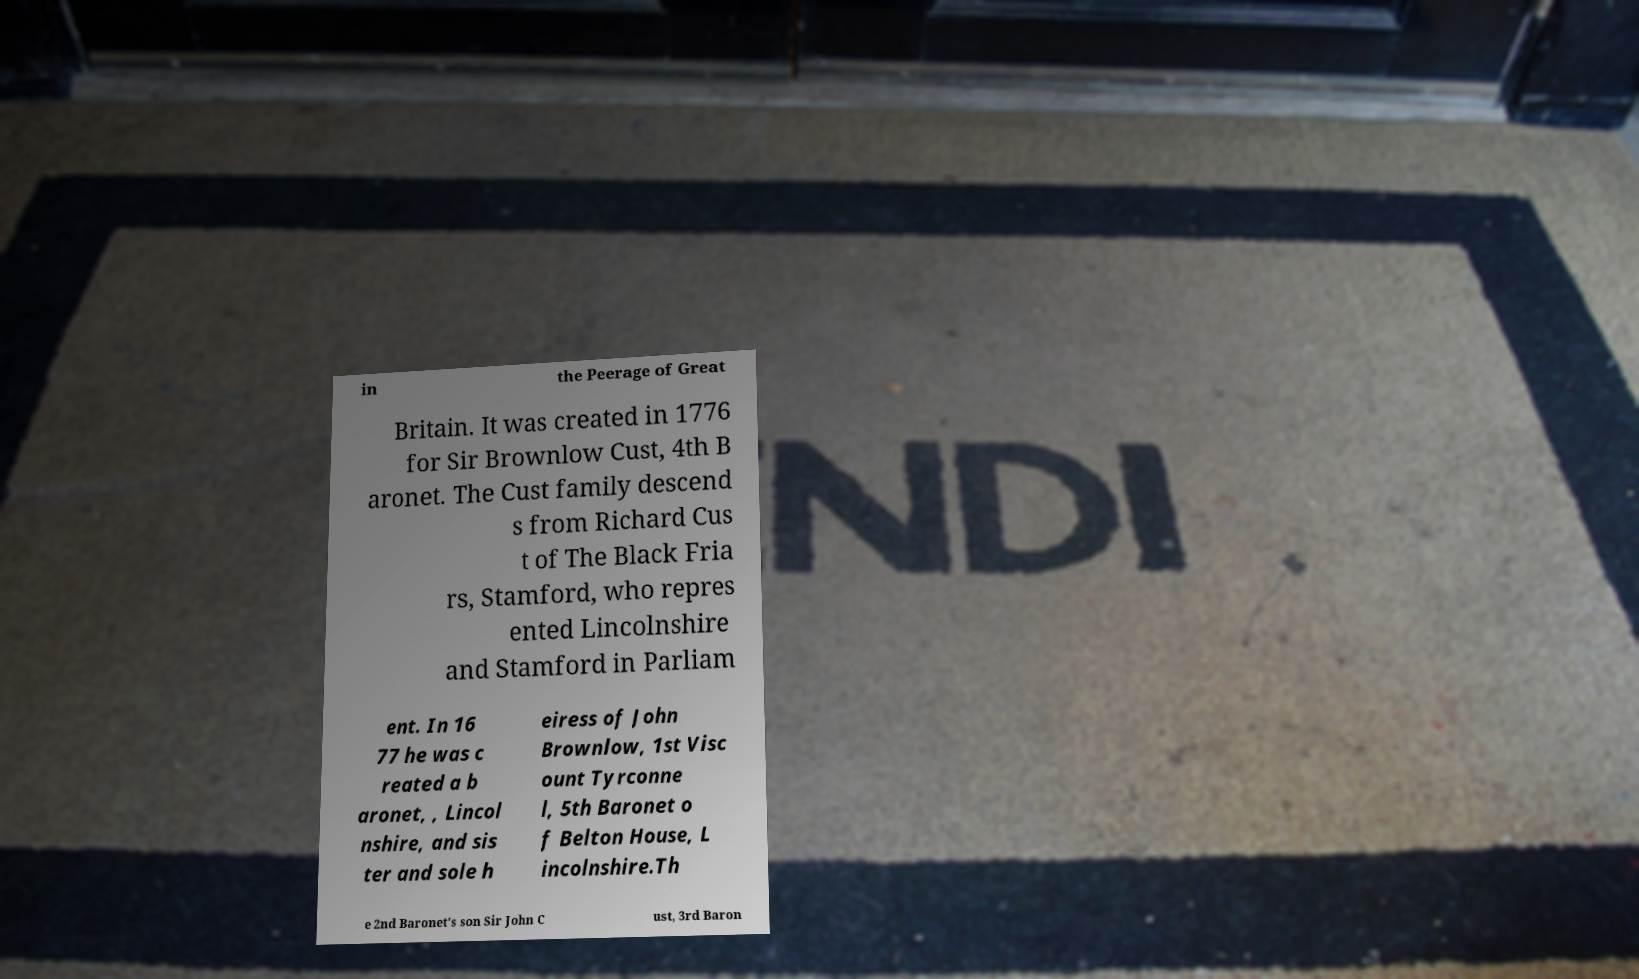Please identify and transcribe the text found in this image. in the Peerage of Great Britain. It was created in 1776 for Sir Brownlow Cust, 4th B aronet. The Cust family descend s from Richard Cus t of The Black Fria rs, Stamford, who repres ented Lincolnshire and Stamford in Parliam ent. In 16 77 he was c reated a b aronet, , Lincol nshire, and sis ter and sole h eiress of John Brownlow, 1st Visc ount Tyrconne l, 5th Baronet o f Belton House, L incolnshire.Th e 2nd Baronet's son Sir John C ust, 3rd Baron 